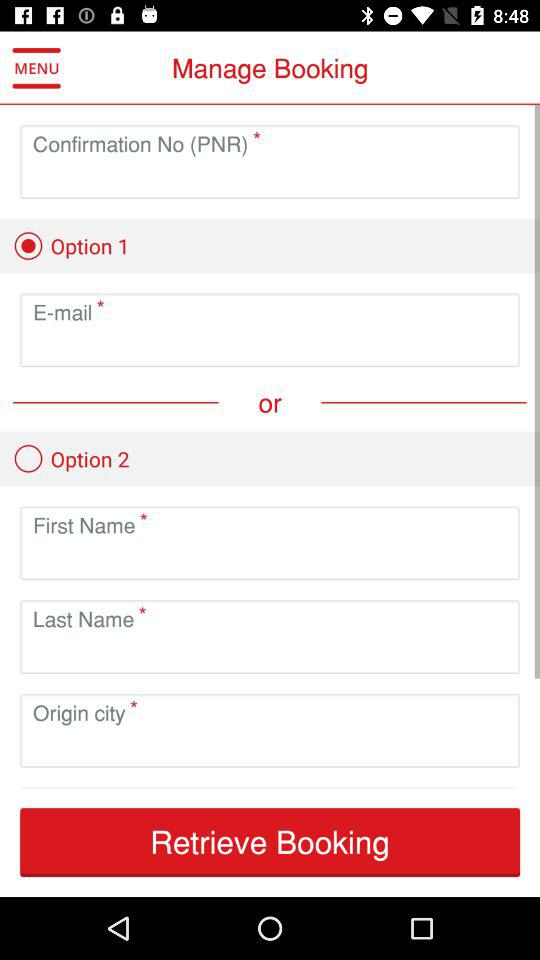How many options are there to retrieve a booking?
Answer the question using a single word or phrase. 2 